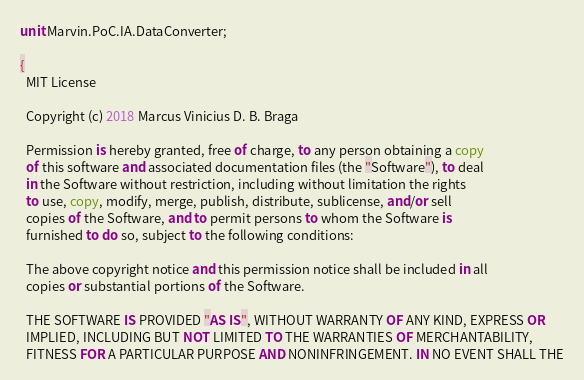<code> <loc_0><loc_0><loc_500><loc_500><_Pascal_>unit Marvin.PoC.IA.DataConverter;

{
  MIT License

  Copyright (c) 2018 Marcus Vinicius D. B. Braga

  Permission is hereby granted, free of charge, to any person obtaining a copy
  of this software and associated documentation files (the "Software"), to deal
  in the Software without restriction, including without limitation the rights
  to use, copy, modify, merge, publish, distribute, sublicense, and/or sell
  copies of the Software, and to permit persons to whom the Software is
  furnished to do so, subject to the following conditions:

  The above copyright notice and this permission notice shall be included in all
  copies or substantial portions of the Software.

  THE SOFTWARE IS PROVIDED "AS IS", WITHOUT WARRANTY OF ANY KIND, EXPRESS OR
  IMPLIED, INCLUDING BUT NOT LIMITED TO THE WARRANTIES OF MERCHANTABILITY,
  FITNESS FOR A PARTICULAR PURPOSE AND NONINFRINGEMENT. IN NO EVENT SHALL THE</code> 